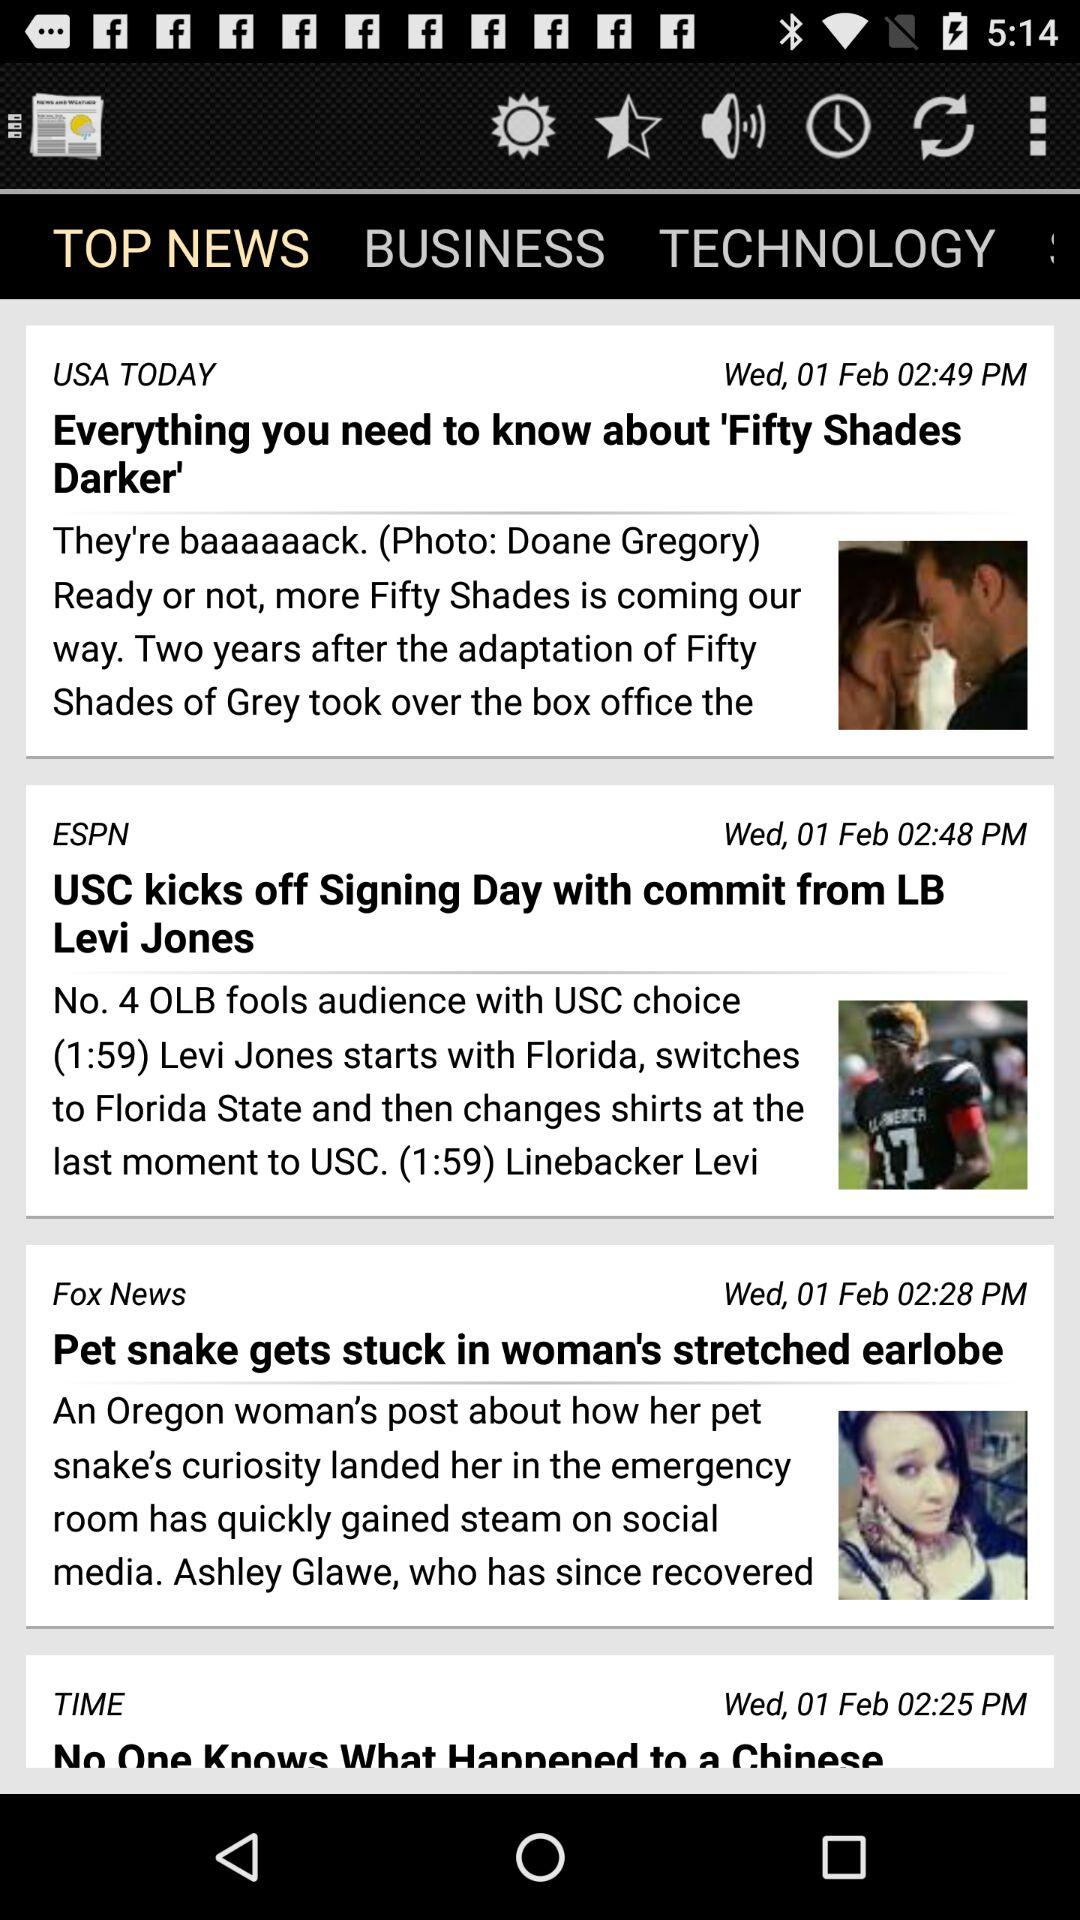What is the title of the ESPN news? The title of the ESPN news is "USC kicks off Signing Day with commit from LB Levi Jones". 